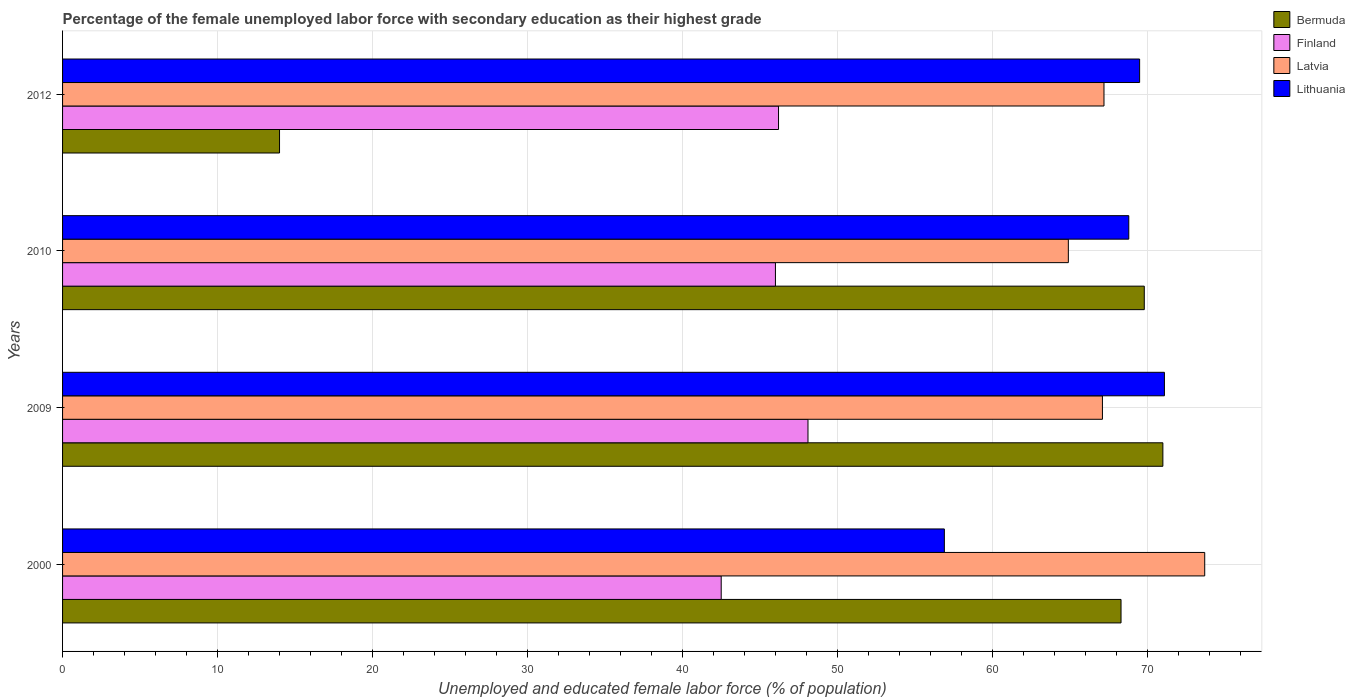How many groups of bars are there?
Ensure brevity in your answer.  4. Are the number of bars per tick equal to the number of legend labels?
Give a very brief answer. Yes. How many bars are there on the 4th tick from the bottom?
Make the answer very short. 4. What is the label of the 2nd group of bars from the top?
Your answer should be compact. 2010. In how many cases, is the number of bars for a given year not equal to the number of legend labels?
Ensure brevity in your answer.  0. What is the percentage of the unemployed female labor force with secondary education in Latvia in 2012?
Your answer should be compact. 67.2. Across all years, what is the maximum percentage of the unemployed female labor force with secondary education in Finland?
Keep it short and to the point. 48.1. Across all years, what is the minimum percentage of the unemployed female labor force with secondary education in Bermuda?
Your answer should be compact. 14. What is the total percentage of the unemployed female labor force with secondary education in Latvia in the graph?
Provide a succinct answer. 272.9. What is the difference between the percentage of the unemployed female labor force with secondary education in Latvia in 2009 and that in 2010?
Provide a succinct answer. 2.2. What is the difference between the percentage of the unemployed female labor force with secondary education in Finland in 2009 and the percentage of the unemployed female labor force with secondary education in Lithuania in 2012?
Offer a terse response. -21.4. What is the average percentage of the unemployed female labor force with secondary education in Finland per year?
Ensure brevity in your answer.  45.7. In the year 2000, what is the difference between the percentage of the unemployed female labor force with secondary education in Latvia and percentage of the unemployed female labor force with secondary education in Lithuania?
Your answer should be compact. 16.8. In how many years, is the percentage of the unemployed female labor force with secondary education in Lithuania greater than 68 %?
Give a very brief answer. 3. What is the ratio of the percentage of the unemployed female labor force with secondary education in Lithuania in 2009 to that in 2012?
Offer a terse response. 1.02. Is the difference between the percentage of the unemployed female labor force with secondary education in Latvia in 2000 and 2009 greater than the difference between the percentage of the unemployed female labor force with secondary education in Lithuania in 2000 and 2009?
Offer a very short reply. Yes. What is the difference between the highest and the second highest percentage of the unemployed female labor force with secondary education in Lithuania?
Give a very brief answer. 1.6. What is the difference between the highest and the lowest percentage of the unemployed female labor force with secondary education in Latvia?
Give a very brief answer. 8.8. In how many years, is the percentage of the unemployed female labor force with secondary education in Bermuda greater than the average percentage of the unemployed female labor force with secondary education in Bermuda taken over all years?
Your response must be concise. 3. Is the sum of the percentage of the unemployed female labor force with secondary education in Lithuania in 2000 and 2010 greater than the maximum percentage of the unemployed female labor force with secondary education in Finland across all years?
Ensure brevity in your answer.  Yes. What does the 4th bar from the top in 2010 represents?
Your answer should be compact. Bermuda. What does the 4th bar from the bottom in 2000 represents?
Offer a terse response. Lithuania. Is it the case that in every year, the sum of the percentage of the unemployed female labor force with secondary education in Lithuania and percentage of the unemployed female labor force with secondary education in Finland is greater than the percentage of the unemployed female labor force with secondary education in Bermuda?
Provide a short and direct response. Yes. How many years are there in the graph?
Provide a short and direct response. 4. What is the difference between two consecutive major ticks on the X-axis?
Provide a short and direct response. 10. Does the graph contain any zero values?
Provide a succinct answer. No. Does the graph contain grids?
Provide a short and direct response. Yes. How many legend labels are there?
Your answer should be very brief. 4. What is the title of the graph?
Provide a short and direct response. Percentage of the female unemployed labor force with secondary education as their highest grade. What is the label or title of the X-axis?
Keep it short and to the point. Unemployed and educated female labor force (% of population). What is the label or title of the Y-axis?
Provide a succinct answer. Years. What is the Unemployed and educated female labor force (% of population) of Bermuda in 2000?
Ensure brevity in your answer.  68.3. What is the Unemployed and educated female labor force (% of population) in Finland in 2000?
Your answer should be very brief. 42.5. What is the Unemployed and educated female labor force (% of population) of Latvia in 2000?
Your answer should be very brief. 73.7. What is the Unemployed and educated female labor force (% of population) of Lithuania in 2000?
Give a very brief answer. 56.9. What is the Unemployed and educated female labor force (% of population) in Bermuda in 2009?
Your answer should be compact. 71. What is the Unemployed and educated female labor force (% of population) of Finland in 2009?
Your answer should be compact. 48.1. What is the Unemployed and educated female labor force (% of population) in Latvia in 2009?
Provide a succinct answer. 67.1. What is the Unemployed and educated female labor force (% of population) of Lithuania in 2009?
Offer a very short reply. 71.1. What is the Unemployed and educated female labor force (% of population) of Bermuda in 2010?
Offer a terse response. 69.8. What is the Unemployed and educated female labor force (% of population) in Latvia in 2010?
Provide a succinct answer. 64.9. What is the Unemployed and educated female labor force (% of population) of Lithuania in 2010?
Ensure brevity in your answer.  68.8. What is the Unemployed and educated female labor force (% of population) in Bermuda in 2012?
Keep it short and to the point. 14. What is the Unemployed and educated female labor force (% of population) of Finland in 2012?
Keep it short and to the point. 46.2. What is the Unemployed and educated female labor force (% of population) in Latvia in 2012?
Offer a very short reply. 67.2. What is the Unemployed and educated female labor force (% of population) of Lithuania in 2012?
Provide a short and direct response. 69.5. Across all years, what is the maximum Unemployed and educated female labor force (% of population) of Bermuda?
Your answer should be very brief. 71. Across all years, what is the maximum Unemployed and educated female labor force (% of population) of Finland?
Keep it short and to the point. 48.1. Across all years, what is the maximum Unemployed and educated female labor force (% of population) of Latvia?
Your response must be concise. 73.7. Across all years, what is the maximum Unemployed and educated female labor force (% of population) of Lithuania?
Ensure brevity in your answer.  71.1. Across all years, what is the minimum Unemployed and educated female labor force (% of population) in Finland?
Provide a short and direct response. 42.5. Across all years, what is the minimum Unemployed and educated female labor force (% of population) in Latvia?
Your answer should be compact. 64.9. Across all years, what is the minimum Unemployed and educated female labor force (% of population) in Lithuania?
Give a very brief answer. 56.9. What is the total Unemployed and educated female labor force (% of population) in Bermuda in the graph?
Keep it short and to the point. 223.1. What is the total Unemployed and educated female labor force (% of population) of Finland in the graph?
Give a very brief answer. 182.8. What is the total Unemployed and educated female labor force (% of population) in Latvia in the graph?
Make the answer very short. 272.9. What is the total Unemployed and educated female labor force (% of population) in Lithuania in the graph?
Give a very brief answer. 266.3. What is the difference between the Unemployed and educated female labor force (% of population) in Bermuda in 2000 and that in 2009?
Your response must be concise. -2.7. What is the difference between the Unemployed and educated female labor force (% of population) of Finland in 2000 and that in 2009?
Keep it short and to the point. -5.6. What is the difference between the Unemployed and educated female labor force (% of population) in Latvia in 2000 and that in 2009?
Make the answer very short. 6.6. What is the difference between the Unemployed and educated female labor force (% of population) of Lithuania in 2000 and that in 2009?
Provide a succinct answer. -14.2. What is the difference between the Unemployed and educated female labor force (% of population) in Finland in 2000 and that in 2010?
Give a very brief answer. -3.5. What is the difference between the Unemployed and educated female labor force (% of population) of Latvia in 2000 and that in 2010?
Give a very brief answer. 8.8. What is the difference between the Unemployed and educated female labor force (% of population) in Bermuda in 2000 and that in 2012?
Offer a very short reply. 54.3. What is the difference between the Unemployed and educated female labor force (% of population) of Bermuda in 2009 and that in 2010?
Provide a short and direct response. 1.2. What is the difference between the Unemployed and educated female labor force (% of population) of Latvia in 2009 and that in 2010?
Your response must be concise. 2.2. What is the difference between the Unemployed and educated female labor force (% of population) of Lithuania in 2009 and that in 2010?
Your response must be concise. 2.3. What is the difference between the Unemployed and educated female labor force (% of population) of Bermuda in 2009 and that in 2012?
Ensure brevity in your answer.  57. What is the difference between the Unemployed and educated female labor force (% of population) of Finland in 2009 and that in 2012?
Your response must be concise. 1.9. What is the difference between the Unemployed and educated female labor force (% of population) of Latvia in 2009 and that in 2012?
Make the answer very short. -0.1. What is the difference between the Unemployed and educated female labor force (% of population) of Bermuda in 2010 and that in 2012?
Provide a short and direct response. 55.8. What is the difference between the Unemployed and educated female labor force (% of population) of Latvia in 2010 and that in 2012?
Your answer should be compact. -2.3. What is the difference between the Unemployed and educated female labor force (% of population) of Lithuania in 2010 and that in 2012?
Make the answer very short. -0.7. What is the difference between the Unemployed and educated female labor force (% of population) of Bermuda in 2000 and the Unemployed and educated female labor force (% of population) of Finland in 2009?
Offer a terse response. 20.2. What is the difference between the Unemployed and educated female labor force (% of population) of Bermuda in 2000 and the Unemployed and educated female labor force (% of population) of Latvia in 2009?
Your response must be concise. 1.2. What is the difference between the Unemployed and educated female labor force (% of population) of Bermuda in 2000 and the Unemployed and educated female labor force (% of population) of Lithuania in 2009?
Your response must be concise. -2.8. What is the difference between the Unemployed and educated female labor force (% of population) in Finland in 2000 and the Unemployed and educated female labor force (% of population) in Latvia in 2009?
Offer a terse response. -24.6. What is the difference between the Unemployed and educated female labor force (% of population) in Finland in 2000 and the Unemployed and educated female labor force (% of population) in Lithuania in 2009?
Keep it short and to the point. -28.6. What is the difference between the Unemployed and educated female labor force (% of population) in Latvia in 2000 and the Unemployed and educated female labor force (% of population) in Lithuania in 2009?
Your response must be concise. 2.6. What is the difference between the Unemployed and educated female labor force (% of population) in Bermuda in 2000 and the Unemployed and educated female labor force (% of population) in Finland in 2010?
Your response must be concise. 22.3. What is the difference between the Unemployed and educated female labor force (% of population) of Bermuda in 2000 and the Unemployed and educated female labor force (% of population) of Lithuania in 2010?
Provide a short and direct response. -0.5. What is the difference between the Unemployed and educated female labor force (% of population) of Finland in 2000 and the Unemployed and educated female labor force (% of population) of Latvia in 2010?
Give a very brief answer. -22.4. What is the difference between the Unemployed and educated female labor force (% of population) of Finland in 2000 and the Unemployed and educated female labor force (% of population) of Lithuania in 2010?
Keep it short and to the point. -26.3. What is the difference between the Unemployed and educated female labor force (% of population) in Latvia in 2000 and the Unemployed and educated female labor force (% of population) in Lithuania in 2010?
Ensure brevity in your answer.  4.9. What is the difference between the Unemployed and educated female labor force (% of population) of Bermuda in 2000 and the Unemployed and educated female labor force (% of population) of Finland in 2012?
Your answer should be very brief. 22.1. What is the difference between the Unemployed and educated female labor force (% of population) of Bermuda in 2000 and the Unemployed and educated female labor force (% of population) of Latvia in 2012?
Ensure brevity in your answer.  1.1. What is the difference between the Unemployed and educated female labor force (% of population) of Finland in 2000 and the Unemployed and educated female labor force (% of population) of Latvia in 2012?
Make the answer very short. -24.7. What is the difference between the Unemployed and educated female labor force (% of population) in Finland in 2000 and the Unemployed and educated female labor force (% of population) in Lithuania in 2012?
Make the answer very short. -27. What is the difference between the Unemployed and educated female labor force (% of population) in Bermuda in 2009 and the Unemployed and educated female labor force (% of population) in Finland in 2010?
Provide a short and direct response. 25. What is the difference between the Unemployed and educated female labor force (% of population) of Bermuda in 2009 and the Unemployed and educated female labor force (% of population) of Lithuania in 2010?
Your response must be concise. 2.2. What is the difference between the Unemployed and educated female labor force (% of population) in Finland in 2009 and the Unemployed and educated female labor force (% of population) in Latvia in 2010?
Offer a terse response. -16.8. What is the difference between the Unemployed and educated female labor force (% of population) in Finland in 2009 and the Unemployed and educated female labor force (% of population) in Lithuania in 2010?
Your answer should be very brief. -20.7. What is the difference between the Unemployed and educated female labor force (% of population) of Latvia in 2009 and the Unemployed and educated female labor force (% of population) of Lithuania in 2010?
Your answer should be very brief. -1.7. What is the difference between the Unemployed and educated female labor force (% of population) in Bermuda in 2009 and the Unemployed and educated female labor force (% of population) in Finland in 2012?
Provide a short and direct response. 24.8. What is the difference between the Unemployed and educated female labor force (% of population) in Bermuda in 2009 and the Unemployed and educated female labor force (% of population) in Latvia in 2012?
Make the answer very short. 3.8. What is the difference between the Unemployed and educated female labor force (% of population) in Bermuda in 2009 and the Unemployed and educated female labor force (% of population) in Lithuania in 2012?
Your answer should be compact. 1.5. What is the difference between the Unemployed and educated female labor force (% of population) in Finland in 2009 and the Unemployed and educated female labor force (% of population) in Latvia in 2012?
Your answer should be compact. -19.1. What is the difference between the Unemployed and educated female labor force (% of population) of Finland in 2009 and the Unemployed and educated female labor force (% of population) of Lithuania in 2012?
Your answer should be very brief. -21.4. What is the difference between the Unemployed and educated female labor force (% of population) of Bermuda in 2010 and the Unemployed and educated female labor force (% of population) of Finland in 2012?
Make the answer very short. 23.6. What is the difference between the Unemployed and educated female labor force (% of population) of Bermuda in 2010 and the Unemployed and educated female labor force (% of population) of Latvia in 2012?
Provide a short and direct response. 2.6. What is the difference between the Unemployed and educated female labor force (% of population) of Finland in 2010 and the Unemployed and educated female labor force (% of population) of Latvia in 2012?
Offer a terse response. -21.2. What is the difference between the Unemployed and educated female labor force (% of population) of Finland in 2010 and the Unemployed and educated female labor force (% of population) of Lithuania in 2012?
Keep it short and to the point. -23.5. What is the average Unemployed and educated female labor force (% of population) of Bermuda per year?
Your answer should be very brief. 55.77. What is the average Unemployed and educated female labor force (% of population) in Finland per year?
Provide a short and direct response. 45.7. What is the average Unemployed and educated female labor force (% of population) of Latvia per year?
Keep it short and to the point. 68.22. What is the average Unemployed and educated female labor force (% of population) in Lithuania per year?
Your answer should be compact. 66.58. In the year 2000, what is the difference between the Unemployed and educated female labor force (% of population) in Bermuda and Unemployed and educated female labor force (% of population) in Finland?
Offer a terse response. 25.8. In the year 2000, what is the difference between the Unemployed and educated female labor force (% of population) of Bermuda and Unemployed and educated female labor force (% of population) of Latvia?
Make the answer very short. -5.4. In the year 2000, what is the difference between the Unemployed and educated female labor force (% of population) of Finland and Unemployed and educated female labor force (% of population) of Latvia?
Give a very brief answer. -31.2. In the year 2000, what is the difference between the Unemployed and educated female labor force (% of population) in Finland and Unemployed and educated female labor force (% of population) in Lithuania?
Make the answer very short. -14.4. In the year 2009, what is the difference between the Unemployed and educated female labor force (% of population) in Bermuda and Unemployed and educated female labor force (% of population) in Finland?
Ensure brevity in your answer.  22.9. In the year 2009, what is the difference between the Unemployed and educated female labor force (% of population) in Bermuda and Unemployed and educated female labor force (% of population) in Latvia?
Provide a short and direct response. 3.9. In the year 2009, what is the difference between the Unemployed and educated female labor force (% of population) of Bermuda and Unemployed and educated female labor force (% of population) of Lithuania?
Provide a short and direct response. -0.1. In the year 2009, what is the difference between the Unemployed and educated female labor force (% of population) in Finland and Unemployed and educated female labor force (% of population) in Latvia?
Keep it short and to the point. -19. In the year 2009, what is the difference between the Unemployed and educated female labor force (% of population) in Finland and Unemployed and educated female labor force (% of population) in Lithuania?
Provide a short and direct response. -23. In the year 2009, what is the difference between the Unemployed and educated female labor force (% of population) of Latvia and Unemployed and educated female labor force (% of population) of Lithuania?
Ensure brevity in your answer.  -4. In the year 2010, what is the difference between the Unemployed and educated female labor force (% of population) in Bermuda and Unemployed and educated female labor force (% of population) in Finland?
Your response must be concise. 23.8. In the year 2010, what is the difference between the Unemployed and educated female labor force (% of population) of Bermuda and Unemployed and educated female labor force (% of population) of Lithuania?
Your answer should be compact. 1. In the year 2010, what is the difference between the Unemployed and educated female labor force (% of population) in Finland and Unemployed and educated female labor force (% of population) in Latvia?
Your answer should be compact. -18.9. In the year 2010, what is the difference between the Unemployed and educated female labor force (% of population) in Finland and Unemployed and educated female labor force (% of population) in Lithuania?
Keep it short and to the point. -22.8. In the year 2010, what is the difference between the Unemployed and educated female labor force (% of population) in Latvia and Unemployed and educated female labor force (% of population) in Lithuania?
Provide a succinct answer. -3.9. In the year 2012, what is the difference between the Unemployed and educated female labor force (% of population) in Bermuda and Unemployed and educated female labor force (% of population) in Finland?
Your answer should be very brief. -32.2. In the year 2012, what is the difference between the Unemployed and educated female labor force (% of population) in Bermuda and Unemployed and educated female labor force (% of population) in Latvia?
Your response must be concise. -53.2. In the year 2012, what is the difference between the Unemployed and educated female labor force (% of population) of Bermuda and Unemployed and educated female labor force (% of population) of Lithuania?
Give a very brief answer. -55.5. In the year 2012, what is the difference between the Unemployed and educated female labor force (% of population) of Finland and Unemployed and educated female labor force (% of population) of Latvia?
Your answer should be compact. -21. In the year 2012, what is the difference between the Unemployed and educated female labor force (% of population) in Finland and Unemployed and educated female labor force (% of population) in Lithuania?
Provide a succinct answer. -23.3. In the year 2012, what is the difference between the Unemployed and educated female labor force (% of population) in Latvia and Unemployed and educated female labor force (% of population) in Lithuania?
Provide a short and direct response. -2.3. What is the ratio of the Unemployed and educated female labor force (% of population) of Finland in 2000 to that in 2009?
Offer a very short reply. 0.88. What is the ratio of the Unemployed and educated female labor force (% of population) in Latvia in 2000 to that in 2009?
Your answer should be compact. 1.1. What is the ratio of the Unemployed and educated female labor force (% of population) of Lithuania in 2000 to that in 2009?
Your answer should be very brief. 0.8. What is the ratio of the Unemployed and educated female labor force (% of population) of Bermuda in 2000 to that in 2010?
Ensure brevity in your answer.  0.98. What is the ratio of the Unemployed and educated female labor force (% of population) of Finland in 2000 to that in 2010?
Your response must be concise. 0.92. What is the ratio of the Unemployed and educated female labor force (% of population) of Latvia in 2000 to that in 2010?
Offer a very short reply. 1.14. What is the ratio of the Unemployed and educated female labor force (% of population) in Lithuania in 2000 to that in 2010?
Make the answer very short. 0.83. What is the ratio of the Unemployed and educated female labor force (% of population) of Bermuda in 2000 to that in 2012?
Your answer should be very brief. 4.88. What is the ratio of the Unemployed and educated female labor force (% of population) of Finland in 2000 to that in 2012?
Keep it short and to the point. 0.92. What is the ratio of the Unemployed and educated female labor force (% of population) in Latvia in 2000 to that in 2012?
Your answer should be compact. 1.1. What is the ratio of the Unemployed and educated female labor force (% of population) in Lithuania in 2000 to that in 2012?
Ensure brevity in your answer.  0.82. What is the ratio of the Unemployed and educated female labor force (% of population) in Bermuda in 2009 to that in 2010?
Provide a succinct answer. 1.02. What is the ratio of the Unemployed and educated female labor force (% of population) in Finland in 2009 to that in 2010?
Provide a short and direct response. 1.05. What is the ratio of the Unemployed and educated female labor force (% of population) of Latvia in 2009 to that in 2010?
Offer a terse response. 1.03. What is the ratio of the Unemployed and educated female labor force (% of population) of Lithuania in 2009 to that in 2010?
Make the answer very short. 1.03. What is the ratio of the Unemployed and educated female labor force (% of population) in Bermuda in 2009 to that in 2012?
Provide a succinct answer. 5.07. What is the ratio of the Unemployed and educated female labor force (% of population) of Finland in 2009 to that in 2012?
Make the answer very short. 1.04. What is the ratio of the Unemployed and educated female labor force (% of population) of Latvia in 2009 to that in 2012?
Ensure brevity in your answer.  1. What is the ratio of the Unemployed and educated female labor force (% of population) of Bermuda in 2010 to that in 2012?
Your response must be concise. 4.99. What is the ratio of the Unemployed and educated female labor force (% of population) in Finland in 2010 to that in 2012?
Ensure brevity in your answer.  1. What is the ratio of the Unemployed and educated female labor force (% of population) of Latvia in 2010 to that in 2012?
Keep it short and to the point. 0.97. What is the difference between the highest and the second highest Unemployed and educated female labor force (% of population) of Latvia?
Provide a succinct answer. 6.5. What is the difference between the highest and the lowest Unemployed and educated female labor force (% of population) in Latvia?
Ensure brevity in your answer.  8.8. 